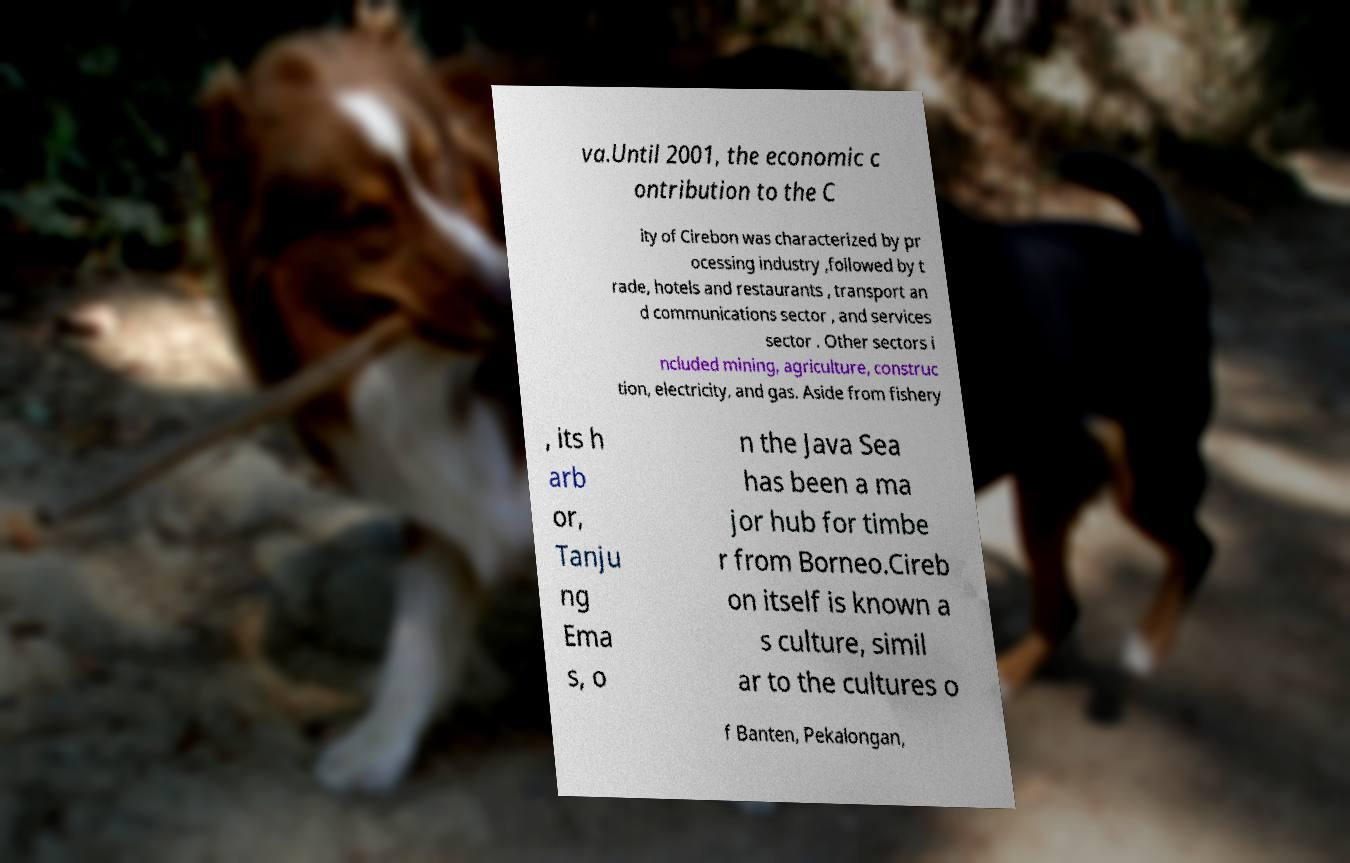Can you read and provide the text displayed in the image?This photo seems to have some interesting text. Can you extract and type it out for me? va.Until 2001, the economic c ontribution to the C ity of Cirebon was characterized by pr ocessing industry ,followed by t rade, hotels and restaurants , transport an d communications sector , and services sector . Other sectors i ncluded mining, agriculture, construc tion, electricity, and gas. Aside from fishery , its h arb or, Tanju ng Ema s, o n the Java Sea has been a ma jor hub for timbe r from Borneo.Cireb on itself is known a s culture, simil ar to the cultures o f Banten, Pekalongan, 